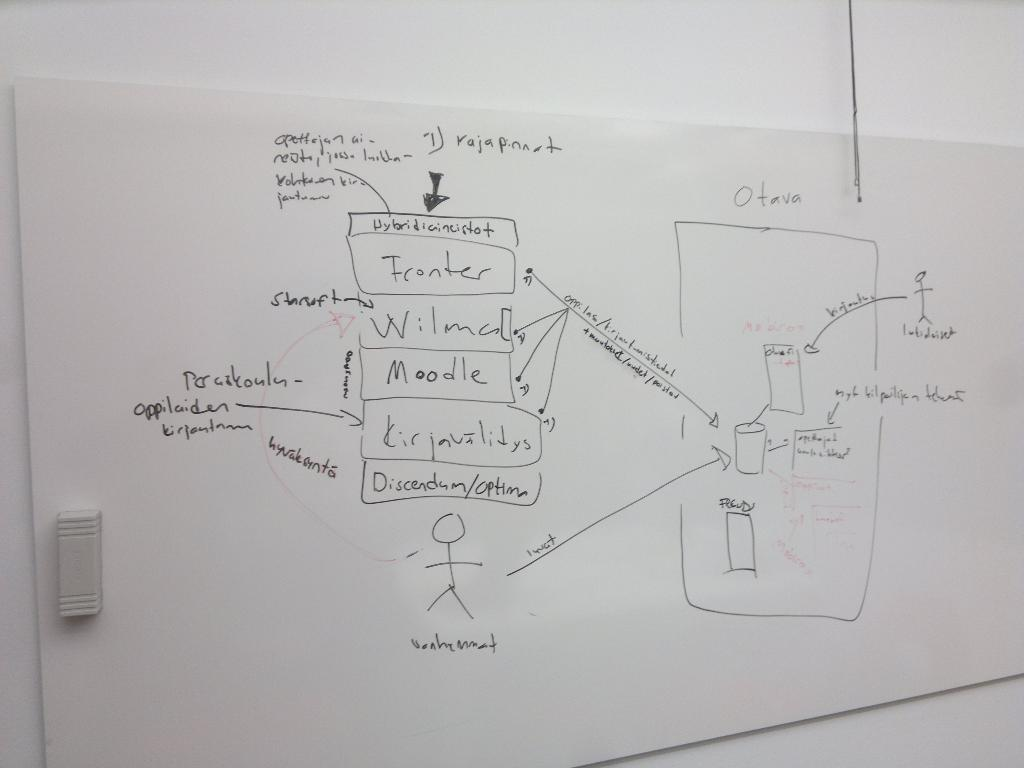<image>
Offer a succinct explanation of the picture presented. A drawing on a whiteboard with lettering in another language including the word moodle. 